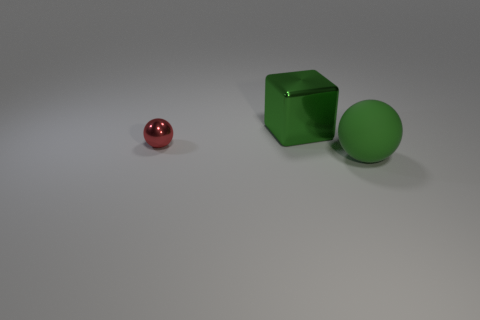What is the shape of the big green metal object behind the large thing that is right of the large green block?
Provide a succinct answer. Cube. What shape is the thing that is both behind the green matte thing and in front of the green cube?
Keep it short and to the point. Sphere. How many things are small spheres or objects that are on the right side of the green cube?
Ensure brevity in your answer.  2. There is another big thing that is the same shape as the red metal object; what is its material?
Provide a succinct answer. Rubber. Is there anything else that has the same material as the small red object?
Offer a terse response. Yes. What is the material of the thing that is both behind the matte ball and right of the tiny red metal object?
Your answer should be very brief. Metal. How many other small red shiny objects are the same shape as the small red shiny object?
Make the answer very short. 0. What color is the small shiny object behind the green thing that is on the right side of the green metallic block?
Give a very brief answer. Red. Are there the same number of small red balls that are on the right side of the large green metal block and tiny metal balls?
Your answer should be very brief. No. Is there a green matte object of the same size as the green metallic block?
Your answer should be very brief. Yes. 